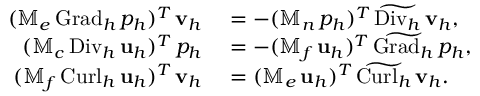<formula> <loc_0><loc_0><loc_500><loc_500>\begin{array} { r l } { ( \mathbb { M } _ { e } \, { G r a d _ { h } } \, p _ { h } ) ^ { T } \, v _ { h } } & = - ( \mathbb { M } _ { n } \, p _ { h } ) ^ { T } \, \widetilde { D i v _ { h } } \, v _ { h } , } \\ { ( \mathbb { M } _ { c } \, { D i v _ { h } } \, u _ { h } ) ^ { T } \, p _ { h } } & = - ( \mathbb { M } _ { f } \, u _ { h } ) ^ { T } \, \widetilde { G r a d _ { h } } \, p _ { h } , } \\ { ( \mathbb { M } _ { f } \, { C u r l _ { h } } \, u _ { h } ) ^ { T } \, v _ { h } } & = ( \mathbb { M } _ { e } \, u _ { h } ) ^ { T } \, \widetilde { C u r l _ { h } } \, v _ { h } . } \end{array}</formula> 